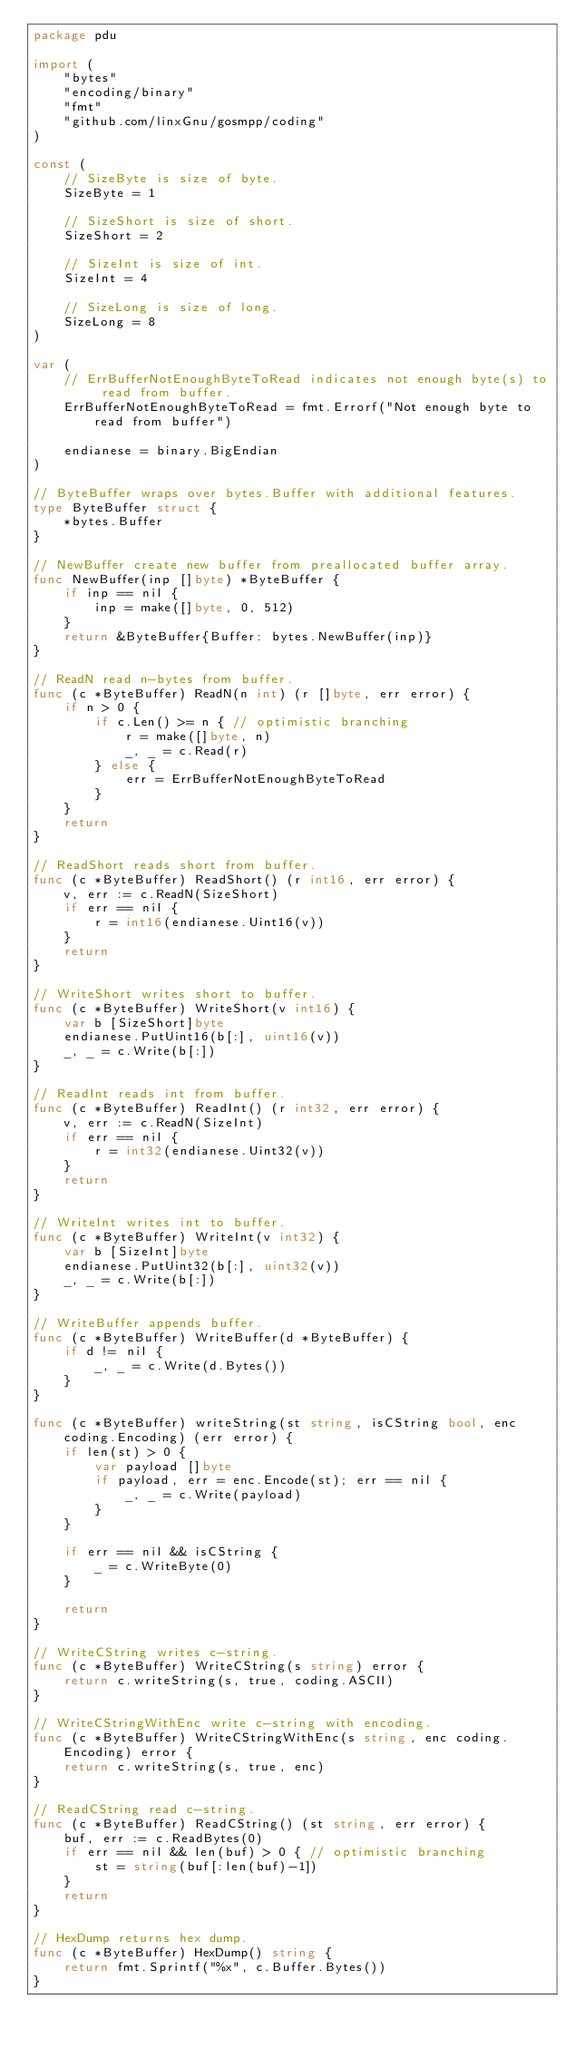Convert code to text. <code><loc_0><loc_0><loc_500><loc_500><_Go_>package pdu

import (
	"bytes"
	"encoding/binary"
	"fmt"
	"github.com/linxGnu/gosmpp/coding"
)

const (
	// SizeByte is size of byte.
	SizeByte = 1

	// SizeShort is size of short.
	SizeShort = 2

	// SizeInt is size of int.
	SizeInt = 4

	// SizeLong is size of long.
	SizeLong = 8
)

var (
	// ErrBufferNotEnoughByteToRead indicates not enough byte(s) to read from buffer.
	ErrBufferNotEnoughByteToRead = fmt.Errorf("Not enough byte to read from buffer")

	endianese = binary.BigEndian
)

// ByteBuffer wraps over bytes.Buffer with additional features.
type ByteBuffer struct {
	*bytes.Buffer
}

// NewBuffer create new buffer from preallocated buffer array.
func NewBuffer(inp []byte) *ByteBuffer {
	if inp == nil {
		inp = make([]byte, 0, 512)
	}
	return &ByteBuffer{Buffer: bytes.NewBuffer(inp)}
}

// ReadN read n-bytes from buffer.
func (c *ByteBuffer) ReadN(n int) (r []byte, err error) {
	if n > 0 {
		if c.Len() >= n { // optimistic branching
			r = make([]byte, n)
			_, _ = c.Read(r)
		} else {
			err = ErrBufferNotEnoughByteToRead
		}
	}
	return
}

// ReadShort reads short from buffer.
func (c *ByteBuffer) ReadShort() (r int16, err error) {
	v, err := c.ReadN(SizeShort)
	if err == nil {
		r = int16(endianese.Uint16(v))
	}
	return
}

// WriteShort writes short to buffer.
func (c *ByteBuffer) WriteShort(v int16) {
	var b [SizeShort]byte
	endianese.PutUint16(b[:], uint16(v))
	_, _ = c.Write(b[:])
}

// ReadInt reads int from buffer.
func (c *ByteBuffer) ReadInt() (r int32, err error) {
	v, err := c.ReadN(SizeInt)
	if err == nil {
		r = int32(endianese.Uint32(v))
	}
	return
}

// WriteInt writes int to buffer.
func (c *ByteBuffer) WriteInt(v int32) {
	var b [SizeInt]byte
	endianese.PutUint32(b[:], uint32(v))
	_, _ = c.Write(b[:])
}

// WriteBuffer appends buffer.
func (c *ByteBuffer) WriteBuffer(d *ByteBuffer) {
	if d != nil {
		_, _ = c.Write(d.Bytes())
	}
}

func (c *ByteBuffer) writeString(st string, isCString bool, enc coding.Encoding) (err error) {
	if len(st) > 0 {
		var payload []byte
		if payload, err = enc.Encode(st); err == nil {
			_, _ = c.Write(payload)
		}
	}

	if err == nil && isCString {
		_ = c.WriteByte(0)
	}

	return
}

// WriteCString writes c-string.
func (c *ByteBuffer) WriteCString(s string) error {
	return c.writeString(s, true, coding.ASCII)
}

// WriteCStringWithEnc write c-string with encoding.
func (c *ByteBuffer) WriteCStringWithEnc(s string, enc coding.Encoding) error {
	return c.writeString(s, true, enc)
}

// ReadCString read c-string.
func (c *ByteBuffer) ReadCString() (st string, err error) {
	buf, err := c.ReadBytes(0)
	if err == nil && len(buf) > 0 { // optimistic branching
		st = string(buf[:len(buf)-1])
	}
	return
}

// HexDump returns hex dump.
func (c *ByteBuffer) HexDump() string {
	return fmt.Sprintf("%x", c.Buffer.Bytes())
}
</code> 